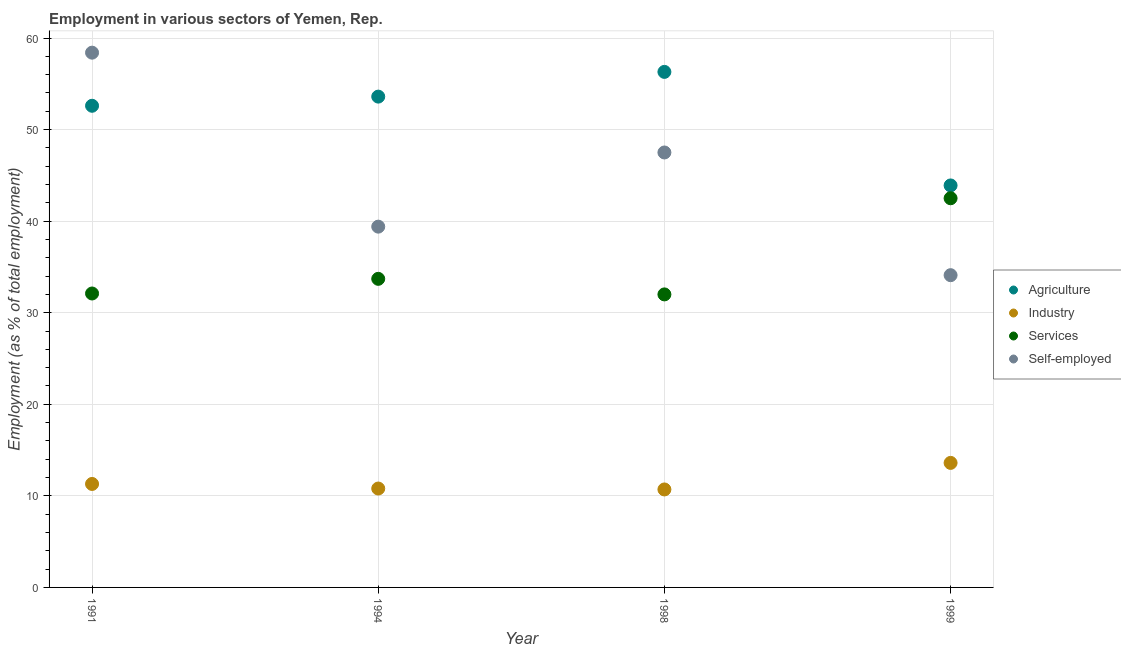Is the number of dotlines equal to the number of legend labels?
Offer a very short reply. Yes. What is the percentage of workers in industry in 1998?
Offer a terse response. 10.7. Across all years, what is the maximum percentage of workers in agriculture?
Provide a short and direct response. 56.3. Across all years, what is the minimum percentage of self employed workers?
Offer a terse response. 34.1. In which year was the percentage of workers in agriculture maximum?
Provide a succinct answer. 1998. In which year was the percentage of self employed workers minimum?
Offer a terse response. 1999. What is the total percentage of self employed workers in the graph?
Your response must be concise. 179.4. What is the difference between the percentage of workers in industry in 1994 and that in 1998?
Provide a short and direct response. 0.1. What is the difference between the percentage of workers in services in 1999 and the percentage of workers in industry in 1991?
Your response must be concise. 31.2. What is the average percentage of self employed workers per year?
Provide a succinct answer. 44.85. In the year 1994, what is the difference between the percentage of workers in industry and percentage of workers in agriculture?
Make the answer very short. -42.8. What is the ratio of the percentage of workers in services in 1991 to that in 1999?
Your answer should be very brief. 0.76. Is the difference between the percentage of self employed workers in 1991 and 1994 greater than the difference between the percentage of workers in agriculture in 1991 and 1994?
Make the answer very short. Yes. What is the difference between the highest and the second highest percentage of workers in industry?
Make the answer very short. 2.3. What is the difference between the highest and the lowest percentage of workers in industry?
Offer a terse response. 2.9. In how many years, is the percentage of workers in industry greater than the average percentage of workers in industry taken over all years?
Keep it short and to the point. 1. Is it the case that in every year, the sum of the percentage of workers in agriculture and percentage of workers in industry is greater than the percentage of workers in services?
Keep it short and to the point. Yes. Is the percentage of workers in industry strictly greater than the percentage of workers in services over the years?
Make the answer very short. No. Is the percentage of workers in agriculture strictly less than the percentage of self employed workers over the years?
Give a very brief answer. No. Where does the legend appear in the graph?
Your response must be concise. Center right. How are the legend labels stacked?
Make the answer very short. Vertical. What is the title of the graph?
Give a very brief answer. Employment in various sectors of Yemen, Rep. Does "Primary" appear as one of the legend labels in the graph?
Offer a very short reply. No. What is the label or title of the Y-axis?
Offer a terse response. Employment (as % of total employment). What is the Employment (as % of total employment) of Agriculture in 1991?
Offer a very short reply. 52.6. What is the Employment (as % of total employment) in Industry in 1991?
Keep it short and to the point. 11.3. What is the Employment (as % of total employment) in Services in 1991?
Give a very brief answer. 32.1. What is the Employment (as % of total employment) in Self-employed in 1991?
Your answer should be very brief. 58.4. What is the Employment (as % of total employment) in Agriculture in 1994?
Provide a succinct answer. 53.6. What is the Employment (as % of total employment) of Industry in 1994?
Provide a short and direct response. 10.8. What is the Employment (as % of total employment) in Services in 1994?
Your response must be concise. 33.7. What is the Employment (as % of total employment) of Self-employed in 1994?
Make the answer very short. 39.4. What is the Employment (as % of total employment) of Agriculture in 1998?
Offer a terse response. 56.3. What is the Employment (as % of total employment) in Industry in 1998?
Keep it short and to the point. 10.7. What is the Employment (as % of total employment) in Services in 1998?
Provide a short and direct response. 32. What is the Employment (as % of total employment) in Self-employed in 1998?
Provide a short and direct response. 47.5. What is the Employment (as % of total employment) of Agriculture in 1999?
Make the answer very short. 43.9. What is the Employment (as % of total employment) in Industry in 1999?
Make the answer very short. 13.6. What is the Employment (as % of total employment) in Services in 1999?
Your response must be concise. 42.5. What is the Employment (as % of total employment) of Self-employed in 1999?
Make the answer very short. 34.1. Across all years, what is the maximum Employment (as % of total employment) in Agriculture?
Your answer should be compact. 56.3. Across all years, what is the maximum Employment (as % of total employment) in Industry?
Provide a short and direct response. 13.6. Across all years, what is the maximum Employment (as % of total employment) of Services?
Provide a short and direct response. 42.5. Across all years, what is the maximum Employment (as % of total employment) of Self-employed?
Provide a short and direct response. 58.4. Across all years, what is the minimum Employment (as % of total employment) in Agriculture?
Provide a succinct answer. 43.9. Across all years, what is the minimum Employment (as % of total employment) of Industry?
Your response must be concise. 10.7. Across all years, what is the minimum Employment (as % of total employment) of Self-employed?
Your response must be concise. 34.1. What is the total Employment (as % of total employment) in Agriculture in the graph?
Offer a terse response. 206.4. What is the total Employment (as % of total employment) in Industry in the graph?
Make the answer very short. 46.4. What is the total Employment (as % of total employment) of Services in the graph?
Give a very brief answer. 140.3. What is the total Employment (as % of total employment) in Self-employed in the graph?
Your answer should be compact. 179.4. What is the difference between the Employment (as % of total employment) in Industry in 1991 and that in 1994?
Give a very brief answer. 0.5. What is the difference between the Employment (as % of total employment) in Self-employed in 1991 and that in 1994?
Ensure brevity in your answer.  19. What is the difference between the Employment (as % of total employment) in Agriculture in 1991 and that in 1998?
Provide a succinct answer. -3.7. What is the difference between the Employment (as % of total employment) in Industry in 1991 and that in 1998?
Your response must be concise. 0.6. What is the difference between the Employment (as % of total employment) of Services in 1991 and that in 1998?
Provide a succinct answer. 0.1. What is the difference between the Employment (as % of total employment) of Self-employed in 1991 and that in 1998?
Give a very brief answer. 10.9. What is the difference between the Employment (as % of total employment) of Agriculture in 1991 and that in 1999?
Your answer should be compact. 8.7. What is the difference between the Employment (as % of total employment) of Services in 1991 and that in 1999?
Provide a short and direct response. -10.4. What is the difference between the Employment (as % of total employment) in Self-employed in 1991 and that in 1999?
Give a very brief answer. 24.3. What is the difference between the Employment (as % of total employment) in Industry in 1994 and that in 1998?
Ensure brevity in your answer.  0.1. What is the difference between the Employment (as % of total employment) of Services in 1994 and that in 1998?
Your answer should be very brief. 1.7. What is the difference between the Employment (as % of total employment) in Agriculture in 1994 and that in 1999?
Your response must be concise. 9.7. What is the difference between the Employment (as % of total employment) of Services in 1994 and that in 1999?
Give a very brief answer. -8.8. What is the difference between the Employment (as % of total employment) of Self-employed in 1994 and that in 1999?
Make the answer very short. 5.3. What is the difference between the Employment (as % of total employment) of Agriculture in 1998 and that in 1999?
Make the answer very short. 12.4. What is the difference between the Employment (as % of total employment) in Industry in 1998 and that in 1999?
Provide a succinct answer. -2.9. What is the difference between the Employment (as % of total employment) in Self-employed in 1998 and that in 1999?
Make the answer very short. 13.4. What is the difference between the Employment (as % of total employment) of Agriculture in 1991 and the Employment (as % of total employment) of Industry in 1994?
Offer a terse response. 41.8. What is the difference between the Employment (as % of total employment) of Agriculture in 1991 and the Employment (as % of total employment) of Self-employed in 1994?
Your response must be concise. 13.2. What is the difference between the Employment (as % of total employment) in Industry in 1991 and the Employment (as % of total employment) in Services in 1994?
Give a very brief answer. -22.4. What is the difference between the Employment (as % of total employment) in Industry in 1991 and the Employment (as % of total employment) in Self-employed in 1994?
Offer a terse response. -28.1. What is the difference between the Employment (as % of total employment) in Services in 1991 and the Employment (as % of total employment) in Self-employed in 1994?
Your answer should be very brief. -7.3. What is the difference between the Employment (as % of total employment) of Agriculture in 1991 and the Employment (as % of total employment) of Industry in 1998?
Provide a short and direct response. 41.9. What is the difference between the Employment (as % of total employment) in Agriculture in 1991 and the Employment (as % of total employment) in Services in 1998?
Your response must be concise. 20.6. What is the difference between the Employment (as % of total employment) in Agriculture in 1991 and the Employment (as % of total employment) in Self-employed in 1998?
Offer a very short reply. 5.1. What is the difference between the Employment (as % of total employment) in Industry in 1991 and the Employment (as % of total employment) in Services in 1998?
Ensure brevity in your answer.  -20.7. What is the difference between the Employment (as % of total employment) of Industry in 1991 and the Employment (as % of total employment) of Self-employed in 1998?
Offer a very short reply. -36.2. What is the difference between the Employment (as % of total employment) in Services in 1991 and the Employment (as % of total employment) in Self-employed in 1998?
Give a very brief answer. -15.4. What is the difference between the Employment (as % of total employment) in Agriculture in 1991 and the Employment (as % of total employment) in Industry in 1999?
Offer a very short reply. 39. What is the difference between the Employment (as % of total employment) in Agriculture in 1991 and the Employment (as % of total employment) in Services in 1999?
Give a very brief answer. 10.1. What is the difference between the Employment (as % of total employment) in Industry in 1991 and the Employment (as % of total employment) in Services in 1999?
Ensure brevity in your answer.  -31.2. What is the difference between the Employment (as % of total employment) of Industry in 1991 and the Employment (as % of total employment) of Self-employed in 1999?
Provide a short and direct response. -22.8. What is the difference between the Employment (as % of total employment) in Agriculture in 1994 and the Employment (as % of total employment) in Industry in 1998?
Ensure brevity in your answer.  42.9. What is the difference between the Employment (as % of total employment) in Agriculture in 1994 and the Employment (as % of total employment) in Services in 1998?
Provide a succinct answer. 21.6. What is the difference between the Employment (as % of total employment) of Industry in 1994 and the Employment (as % of total employment) of Services in 1998?
Offer a very short reply. -21.2. What is the difference between the Employment (as % of total employment) in Industry in 1994 and the Employment (as % of total employment) in Self-employed in 1998?
Offer a terse response. -36.7. What is the difference between the Employment (as % of total employment) in Agriculture in 1994 and the Employment (as % of total employment) in Industry in 1999?
Offer a terse response. 40. What is the difference between the Employment (as % of total employment) of Agriculture in 1994 and the Employment (as % of total employment) of Services in 1999?
Keep it short and to the point. 11.1. What is the difference between the Employment (as % of total employment) of Agriculture in 1994 and the Employment (as % of total employment) of Self-employed in 1999?
Ensure brevity in your answer.  19.5. What is the difference between the Employment (as % of total employment) in Industry in 1994 and the Employment (as % of total employment) in Services in 1999?
Make the answer very short. -31.7. What is the difference between the Employment (as % of total employment) of Industry in 1994 and the Employment (as % of total employment) of Self-employed in 1999?
Ensure brevity in your answer.  -23.3. What is the difference between the Employment (as % of total employment) of Services in 1994 and the Employment (as % of total employment) of Self-employed in 1999?
Ensure brevity in your answer.  -0.4. What is the difference between the Employment (as % of total employment) in Agriculture in 1998 and the Employment (as % of total employment) in Industry in 1999?
Provide a succinct answer. 42.7. What is the difference between the Employment (as % of total employment) of Agriculture in 1998 and the Employment (as % of total employment) of Services in 1999?
Your response must be concise. 13.8. What is the difference between the Employment (as % of total employment) in Industry in 1998 and the Employment (as % of total employment) in Services in 1999?
Your response must be concise. -31.8. What is the difference between the Employment (as % of total employment) of Industry in 1998 and the Employment (as % of total employment) of Self-employed in 1999?
Make the answer very short. -23.4. What is the difference between the Employment (as % of total employment) in Services in 1998 and the Employment (as % of total employment) in Self-employed in 1999?
Provide a succinct answer. -2.1. What is the average Employment (as % of total employment) of Agriculture per year?
Ensure brevity in your answer.  51.6. What is the average Employment (as % of total employment) of Services per year?
Give a very brief answer. 35.08. What is the average Employment (as % of total employment) in Self-employed per year?
Offer a terse response. 44.85. In the year 1991, what is the difference between the Employment (as % of total employment) in Agriculture and Employment (as % of total employment) in Industry?
Keep it short and to the point. 41.3. In the year 1991, what is the difference between the Employment (as % of total employment) in Agriculture and Employment (as % of total employment) in Services?
Ensure brevity in your answer.  20.5. In the year 1991, what is the difference between the Employment (as % of total employment) of Industry and Employment (as % of total employment) of Services?
Your response must be concise. -20.8. In the year 1991, what is the difference between the Employment (as % of total employment) of Industry and Employment (as % of total employment) of Self-employed?
Offer a very short reply. -47.1. In the year 1991, what is the difference between the Employment (as % of total employment) in Services and Employment (as % of total employment) in Self-employed?
Your answer should be compact. -26.3. In the year 1994, what is the difference between the Employment (as % of total employment) of Agriculture and Employment (as % of total employment) of Industry?
Keep it short and to the point. 42.8. In the year 1994, what is the difference between the Employment (as % of total employment) of Industry and Employment (as % of total employment) of Services?
Give a very brief answer. -22.9. In the year 1994, what is the difference between the Employment (as % of total employment) of Industry and Employment (as % of total employment) of Self-employed?
Provide a succinct answer. -28.6. In the year 1994, what is the difference between the Employment (as % of total employment) of Services and Employment (as % of total employment) of Self-employed?
Offer a very short reply. -5.7. In the year 1998, what is the difference between the Employment (as % of total employment) of Agriculture and Employment (as % of total employment) of Industry?
Give a very brief answer. 45.6. In the year 1998, what is the difference between the Employment (as % of total employment) of Agriculture and Employment (as % of total employment) of Services?
Ensure brevity in your answer.  24.3. In the year 1998, what is the difference between the Employment (as % of total employment) of Agriculture and Employment (as % of total employment) of Self-employed?
Provide a succinct answer. 8.8. In the year 1998, what is the difference between the Employment (as % of total employment) of Industry and Employment (as % of total employment) of Services?
Your response must be concise. -21.3. In the year 1998, what is the difference between the Employment (as % of total employment) of Industry and Employment (as % of total employment) of Self-employed?
Your answer should be compact. -36.8. In the year 1998, what is the difference between the Employment (as % of total employment) of Services and Employment (as % of total employment) of Self-employed?
Ensure brevity in your answer.  -15.5. In the year 1999, what is the difference between the Employment (as % of total employment) of Agriculture and Employment (as % of total employment) of Industry?
Provide a short and direct response. 30.3. In the year 1999, what is the difference between the Employment (as % of total employment) of Industry and Employment (as % of total employment) of Services?
Keep it short and to the point. -28.9. In the year 1999, what is the difference between the Employment (as % of total employment) in Industry and Employment (as % of total employment) in Self-employed?
Your answer should be compact. -20.5. In the year 1999, what is the difference between the Employment (as % of total employment) in Services and Employment (as % of total employment) in Self-employed?
Make the answer very short. 8.4. What is the ratio of the Employment (as % of total employment) of Agriculture in 1991 to that in 1994?
Provide a short and direct response. 0.98. What is the ratio of the Employment (as % of total employment) in Industry in 1991 to that in 1994?
Your answer should be very brief. 1.05. What is the ratio of the Employment (as % of total employment) of Services in 1991 to that in 1994?
Offer a terse response. 0.95. What is the ratio of the Employment (as % of total employment) of Self-employed in 1991 to that in 1994?
Your answer should be very brief. 1.48. What is the ratio of the Employment (as % of total employment) of Agriculture in 1991 to that in 1998?
Offer a terse response. 0.93. What is the ratio of the Employment (as % of total employment) of Industry in 1991 to that in 1998?
Your response must be concise. 1.06. What is the ratio of the Employment (as % of total employment) in Services in 1991 to that in 1998?
Provide a short and direct response. 1. What is the ratio of the Employment (as % of total employment) of Self-employed in 1991 to that in 1998?
Your answer should be very brief. 1.23. What is the ratio of the Employment (as % of total employment) in Agriculture in 1991 to that in 1999?
Ensure brevity in your answer.  1.2. What is the ratio of the Employment (as % of total employment) in Industry in 1991 to that in 1999?
Your answer should be very brief. 0.83. What is the ratio of the Employment (as % of total employment) in Services in 1991 to that in 1999?
Provide a succinct answer. 0.76. What is the ratio of the Employment (as % of total employment) in Self-employed in 1991 to that in 1999?
Keep it short and to the point. 1.71. What is the ratio of the Employment (as % of total employment) in Industry in 1994 to that in 1998?
Your response must be concise. 1.01. What is the ratio of the Employment (as % of total employment) of Services in 1994 to that in 1998?
Provide a succinct answer. 1.05. What is the ratio of the Employment (as % of total employment) in Self-employed in 1994 to that in 1998?
Give a very brief answer. 0.83. What is the ratio of the Employment (as % of total employment) in Agriculture in 1994 to that in 1999?
Your answer should be compact. 1.22. What is the ratio of the Employment (as % of total employment) in Industry in 1994 to that in 1999?
Your answer should be very brief. 0.79. What is the ratio of the Employment (as % of total employment) in Services in 1994 to that in 1999?
Your response must be concise. 0.79. What is the ratio of the Employment (as % of total employment) of Self-employed in 1994 to that in 1999?
Keep it short and to the point. 1.16. What is the ratio of the Employment (as % of total employment) in Agriculture in 1998 to that in 1999?
Your response must be concise. 1.28. What is the ratio of the Employment (as % of total employment) of Industry in 1998 to that in 1999?
Ensure brevity in your answer.  0.79. What is the ratio of the Employment (as % of total employment) in Services in 1998 to that in 1999?
Provide a short and direct response. 0.75. What is the ratio of the Employment (as % of total employment) of Self-employed in 1998 to that in 1999?
Keep it short and to the point. 1.39. What is the difference between the highest and the second highest Employment (as % of total employment) in Agriculture?
Keep it short and to the point. 2.7. What is the difference between the highest and the second highest Employment (as % of total employment) of Services?
Ensure brevity in your answer.  8.8. What is the difference between the highest and the second highest Employment (as % of total employment) in Self-employed?
Give a very brief answer. 10.9. What is the difference between the highest and the lowest Employment (as % of total employment) of Services?
Offer a very short reply. 10.5. What is the difference between the highest and the lowest Employment (as % of total employment) in Self-employed?
Provide a succinct answer. 24.3. 